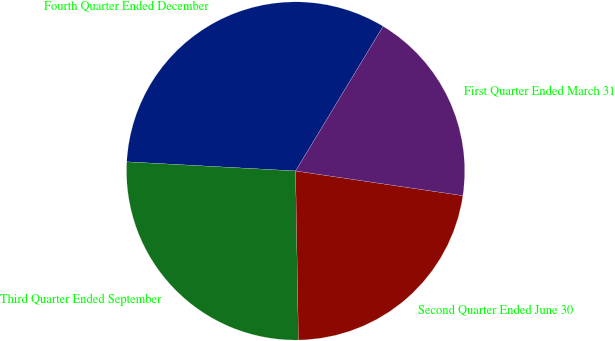Convert chart to OTSL. <chart><loc_0><loc_0><loc_500><loc_500><pie_chart><fcel>Fourth Quarter Ended December<fcel>Third Quarter Ended September<fcel>Second Quarter Ended June 30<fcel>First Quarter Ended March 31<nl><fcel>32.8%<fcel>26.13%<fcel>22.4%<fcel>18.67%<nl></chart> 